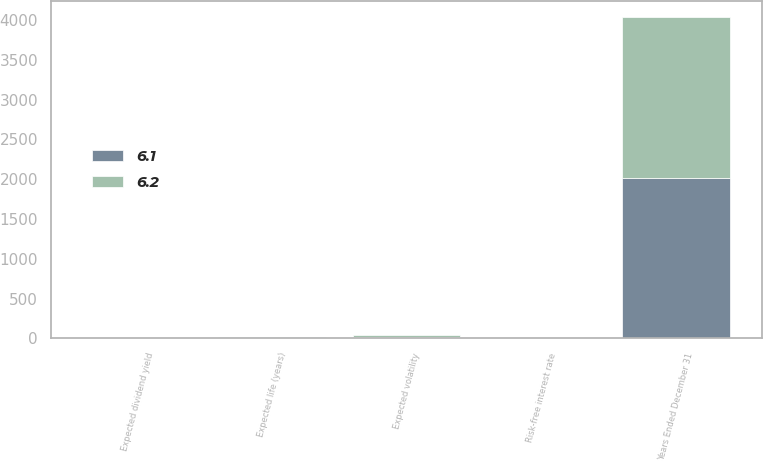Convert chart. <chart><loc_0><loc_0><loc_500><loc_500><stacked_bar_chart><ecel><fcel>Years Ended December 31<fcel>Expected dividend yield<fcel>Risk-free interest rate<fcel>Expected volatility<fcel>Expected life (years)<nl><fcel>6.2<fcel>2017<fcel>3.6<fcel>2<fcel>17.8<fcel>6.1<nl><fcel>6.1<fcel>2016<fcel>3.8<fcel>1.4<fcel>19.6<fcel>6.2<nl></chart> 